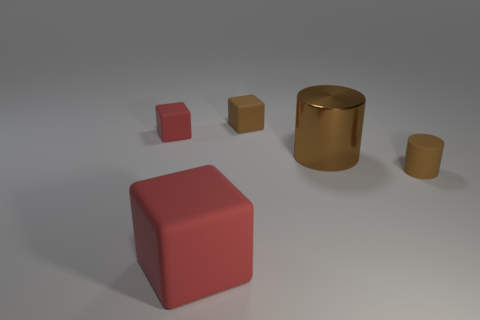Are there any other things that are the same material as the large cylinder?
Provide a short and direct response. No. Does the red object in front of the big cylinder have the same material as the big cylinder?
Keep it short and to the point. No. Is the shape of the large matte object the same as the small red matte thing?
Provide a succinct answer. Yes. What is the shape of the tiny rubber object that is in front of the red matte cube that is behind the cylinder that is on the right side of the large brown cylinder?
Provide a short and direct response. Cylinder. There is a small rubber thing to the right of the brown matte cube; does it have the same shape as the large object that is on the right side of the large red rubber thing?
Ensure brevity in your answer.  Yes. Are there any large blue cylinders made of the same material as the brown block?
Offer a terse response. No. What color is the large matte thing to the right of the red cube that is behind the object in front of the brown matte cylinder?
Your answer should be compact. Red. Do the small brown thing in front of the metal cylinder and the small red block that is behind the big rubber block have the same material?
Give a very brief answer. Yes. What is the shape of the large object that is behind the small rubber cylinder?
Make the answer very short. Cylinder. What number of things are big matte things or rubber things right of the large rubber block?
Provide a succinct answer. 3. 